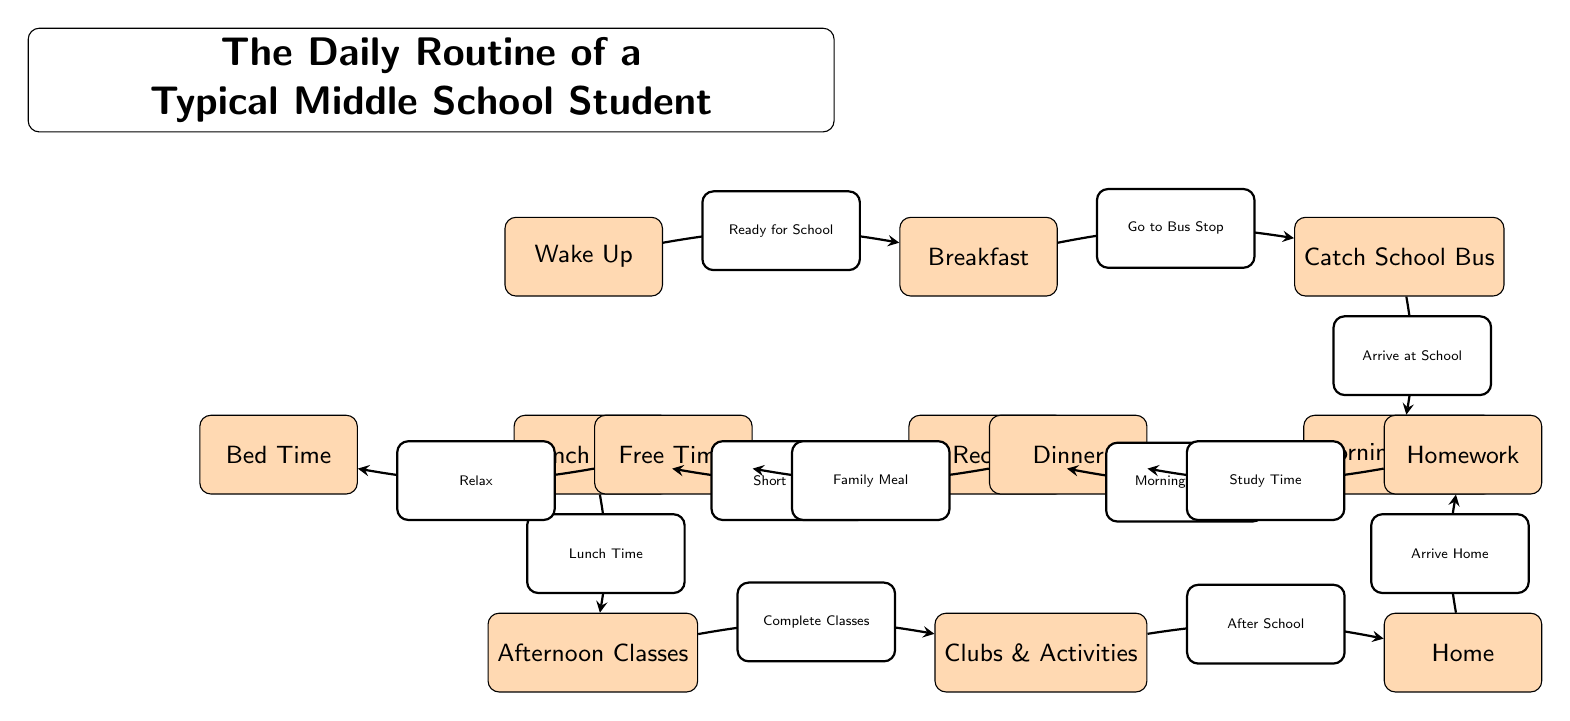What is the first activity in the daily routine? The diagram shows the first activity at the top, which is labeled "Wake Up."
Answer: Wake Up How many activities are listed in the daily routine? To count the activities, I can identify each labeled node in the diagram. There are 12 distinct activities represented in total.
Answer: 12 Which activity comes after "Lunch Break"? By following the arrows from "Lunch Break," the next node is "Afternoon Classes," indicating that this is the subsequent activity.
Answer: Afternoon Classes What is the last activity in the daily routine? The last activity is at the bottom of the diagram, which is labeled "Bed Time."
Answer: Bed Time What is the connection between "Homework" and "Dinner"? The arrow from "Homework" points to "Dinner," indicating the flow of activities. This suggests that after doing homework, the next activity is having dinner.
Answer: Study Time What does the arrow from "Clubs & Activities" represent? The arrow from "Clubs & Activities" to "Home" represents the transition from the end of the clubs and activities back home after school.
Answer: After School What is the duration of the "Recess" as implied by the flow? The arrow from "Morning Classes" to "Recess" suggests a short break between classes, but the exact duration isn't specified. However, it implies a temporary pause in studies.
Answer: Short Break How do "Free Time" and "Bed Time" relate in the routine? The arrow from "Free Time" to "Bed Time" indicates that after having free time, the final activity before sleeping is to go to bed.
Answer: Relax 